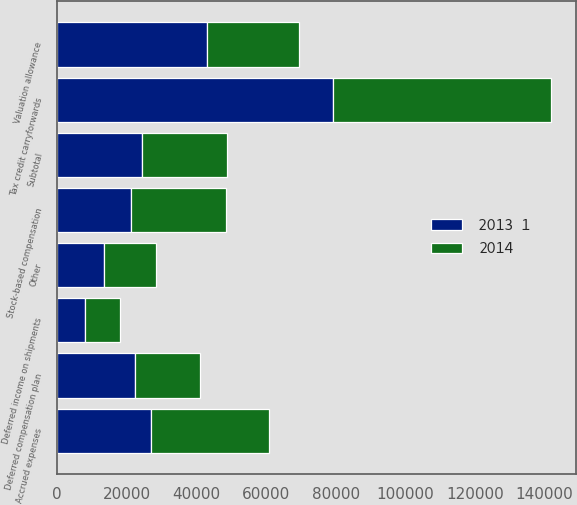Convert chart to OTSL. <chart><loc_0><loc_0><loc_500><loc_500><stacked_bar_chart><ecel><fcel>Stock-based compensation<fcel>Deferred income on shipments<fcel>Accrued expenses<fcel>Tax credit carryforwards<fcel>Deferred compensation plan<fcel>Other<fcel>Subtotal<fcel>Valuation allowance<nl><fcel>2013  1<fcel>21142<fcel>8097<fcel>26864<fcel>79272<fcel>22280<fcel>13420<fcel>24340.5<fcel>43004<nl><fcel>2014<fcel>27481<fcel>10043<fcel>33859<fcel>62723<fcel>18769<fcel>14948<fcel>24340.5<fcel>26401<nl></chart> 